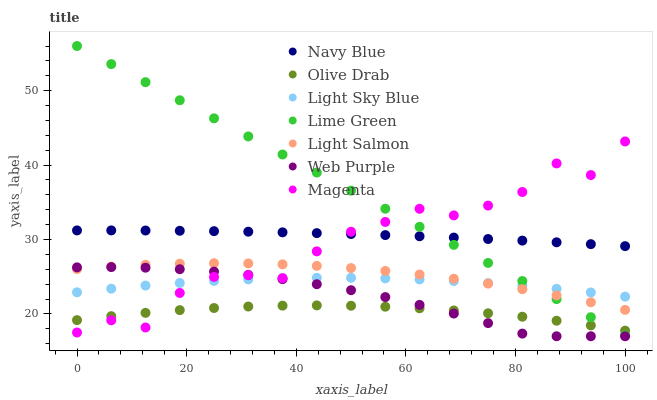Does Olive Drab have the minimum area under the curve?
Answer yes or no. Yes. Does Lime Green have the maximum area under the curve?
Answer yes or no. Yes. Does Navy Blue have the minimum area under the curve?
Answer yes or no. No. Does Navy Blue have the maximum area under the curve?
Answer yes or no. No. Is Lime Green the smoothest?
Answer yes or no. Yes. Is Magenta the roughest?
Answer yes or no. Yes. Is Navy Blue the smoothest?
Answer yes or no. No. Is Navy Blue the roughest?
Answer yes or no. No. Does Web Purple have the lowest value?
Answer yes or no. Yes. Does Navy Blue have the lowest value?
Answer yes or no. No. Does Lime Green have the highest value?
Answer yes or no. Yes. Does Navy Blue have the highest value?
Answer yes or no. No. Is Olive Drab less than Light Sky Blue?
Answer yes or no. Yes. Is Navy Blue greater than Web Purple?
Answer yes or no. Yes. Does Light Sky Blue intersect Light Salmon?
Answer yes or no. Yes. Is Light Sky Blue less than Light Salmon?
Answer yes or no. No. Is Light Sky Blue greater than Light Salmon?
Answer yes or no. No. Does Olive Drab intersect Light Sky Blue?
Answer yes or no. No. 